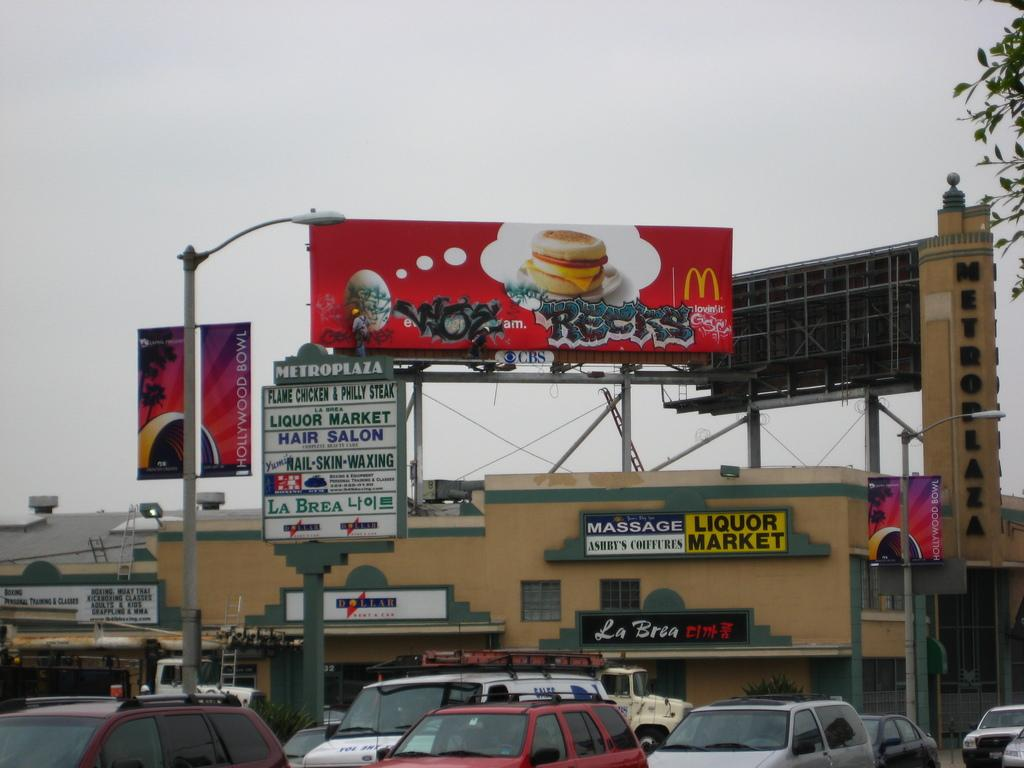<image>
Render a clear and concise summary of the photo. A McDonalds billboard over a store called Liquor Market. 